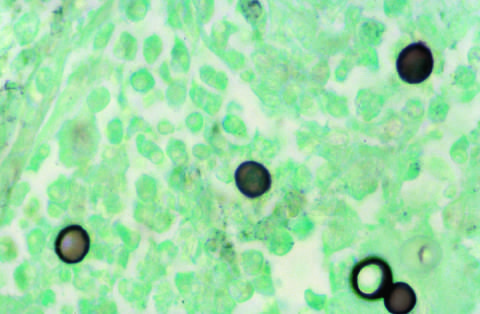does silver stain highlight the broad-based budding seen in blastomyces immitis organisms?
Answer the question using a single word or phrase. Yes 